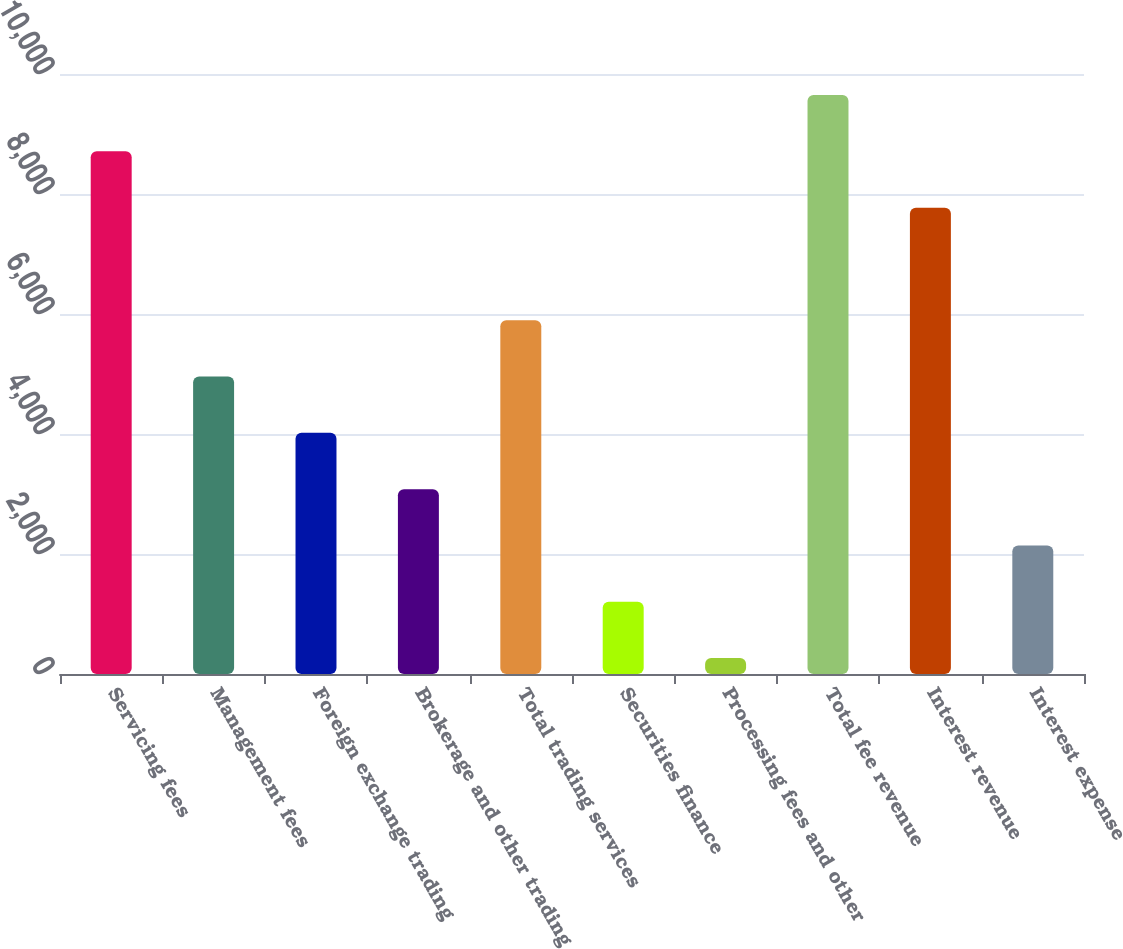Convert chart. <chart><loc_0><loc_0><loc_500><loc_500><bar_chart><fcel>Servicing fees<fcel>Management fees<fcel>Foreign exchange trading<fcel>Brokerage and other trading<fcel>Total trading services<fcel>Securities finance<fcel>Processing fees and other<fcel>Total fee revenue<fcel>Interest revenue<fcel>Interest expense<nl><fcel>8710.7<fcel>4957.5<fcel>4019.2<fcel>3080.9<fcel>5895.8<fcel>1204.3<fcel>266<fcel>9649<fcel>7772.4<fcel>2142.6<nl></chart> 